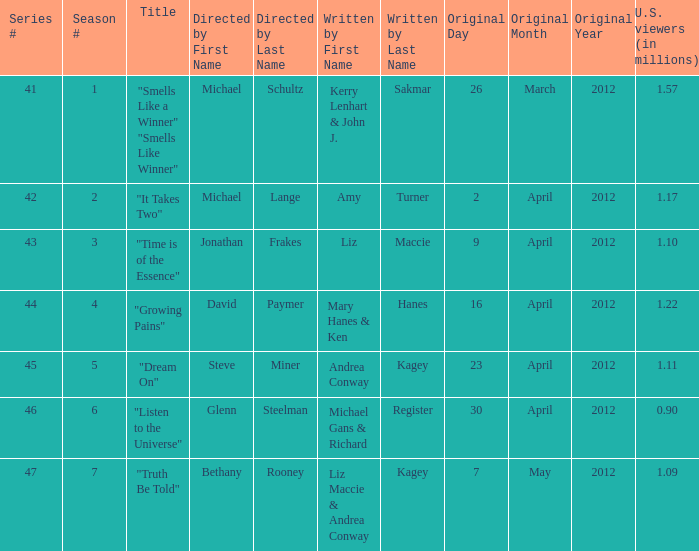What is the name of the episodes which had 1.22 million U.S. viewers? "Growing Pains". 